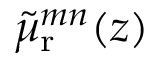<formula> <loc_0><loc_0><loc_500><loc_500>{ \tilde { \mu } _ { r } } ^ { m n } ( z )</formula> 